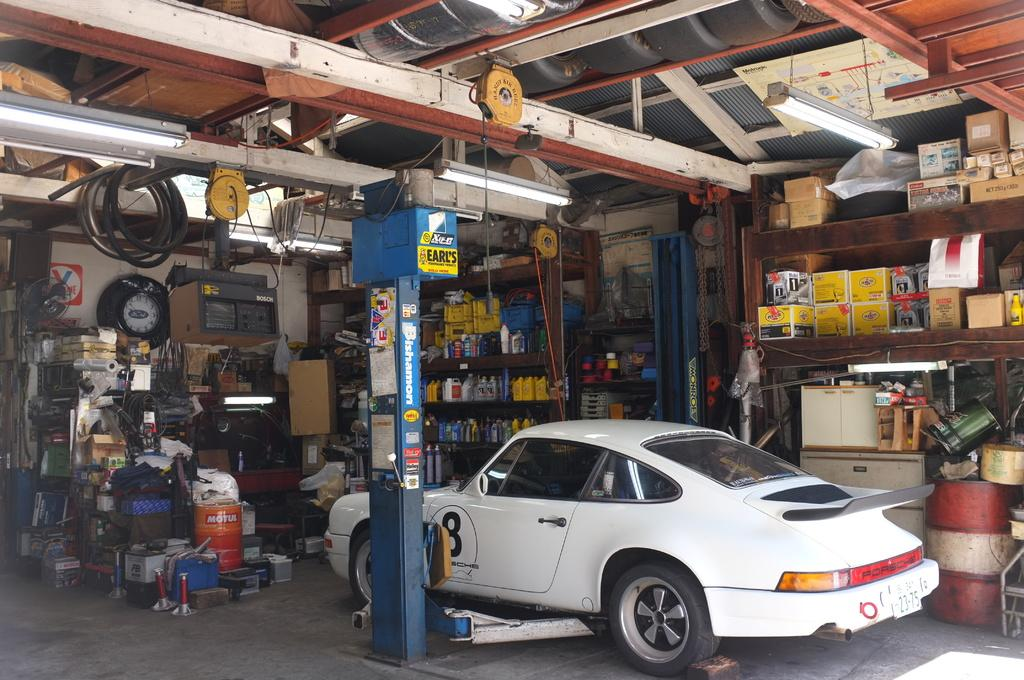What is on the ground in the image? There is a car on the ground in the image. What type of structure can be seen in the image? There is a pillar in the image. What items are present in the image that are typically used for storage? There are boxes in the image. What can be seen in the image that is used for holding liquids? There are bottles in racks in the image. What device is visible in the image that is used for cooling or circulating air? There is a fan in the image. Can you describe any other objects visible in the image? There are other objects visible in the image, but their specific details are not mentioned in the provided facts. What type of rhythm can be heard coming from the hospital in the image? There is no hospital or rhythm present in the image; it features a car, a pillar, boxes, bottles in racks, and a fan. 